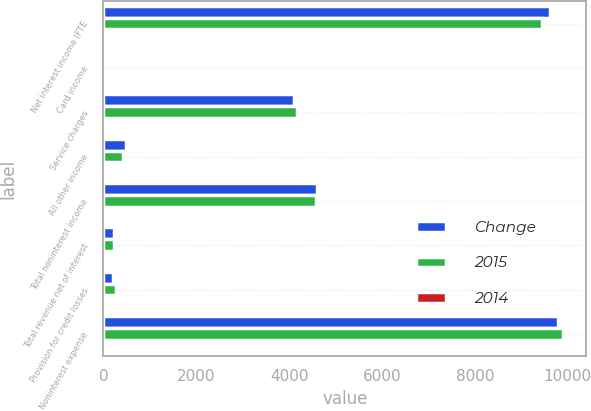Convert chart to OTSL. <chart><loc_0><loc_0><loc_500><loc_500><stacked_bar_chart><ecel><fcel>Net interest income (FTE<fcel>Card income<fcel>Service charges<fcel>All other income<fcel>Total noninterest income<fcel>Total revenue net of interest<fcel>Provision for credit losses<fcel>Noninterest expense<nl><fcel>Change<fcel>9624<fcel>11<fcel>4100<fcel>482<fcel>4593<fcel>233.5<fcel>199<fcel>9792<nl><fcel>2015<fcel>9436<fcel>10<fcel>4159<fcel>418<fcel>4587<fcel>233.5<fcel>268<fcel>9905<nl><fcel>2014<fcel>2<fcel>2<fcel>1<fcel>5<fcel>1<fcel>1<fcel>6<fcel>2<nl></chart> 